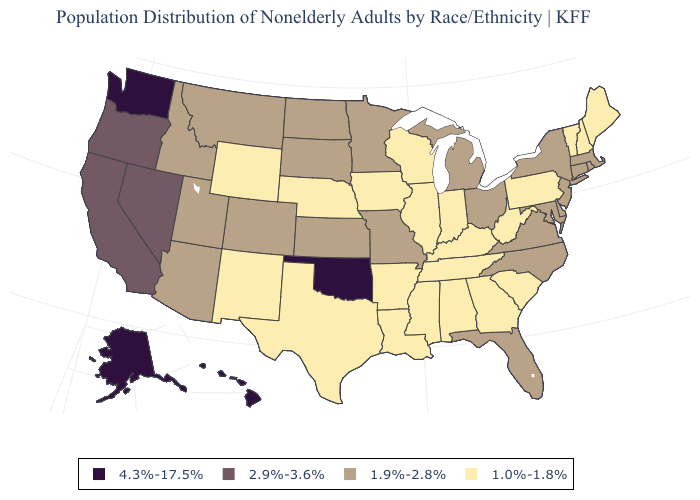What is the highest value in the MidWest ?
Short answer required. 1.9%-2.8%. Name the states that have a value in the range 2.9%-3.6%?
Concise answer only. California, Nevada, Oregon. Which states hav the highest value in the MidWest?
Concise answer only. Kansas, Michigan, Minnesota, Missouri, North Dakota, Ohio, South Dakota. Does West Virginia have the lowest value in the South?
Short answer required. Yes. Name the states that have a value in the range 1.0%-1.8%?
Short answer required. Alabama, Arkansas, Georgia, Illinois, Indiana, Iowa, Kentucky, Louisiana, Maine, Mississippi, Nebraska, New Hampshire, New Mexico, Pennsylvania, South Carolina, Tennessee, Texas, Vermont, West Virginia, Wisconsin, Wyoming. Is the legend a continuous bar?
Write a very short answer. No. What is the value of Maine?
Short answer required. 1.0%-1.8%. Does the first symbol in the legend represent the smallest category?
Answer briefly. No. Does the map have missing data?
Answer briefly. No. What is the value of New York?
Give a very brief answer. 1.9%-2.8%. Which states hav the highest value in the Northeast?
Short answer required. Connecticut, Massachusetts, New Jersey, New York, Rhode Island. What is the value of New Mexico?
Quick response, please. 1.0%-1.8%. Name the states that have a value in the range 1.9%-2.8%?
Quick response, please. Arizona, Colorado, Connecticut, Delaware, Florida, Idaho, Kansas, Maryland, Massachusetts, Michigan, Minnesota, Missouri, Montana, New Jersey, New York, North Carolina, North Dakota, Ohio, Rhode Island, South Dakota, Utah, Virginia. What is the value of Colorado?
Concise answer only. 1.9%-2.8%. Does Oklahoma have the lowest value in the USA?
Short answer required. No. 